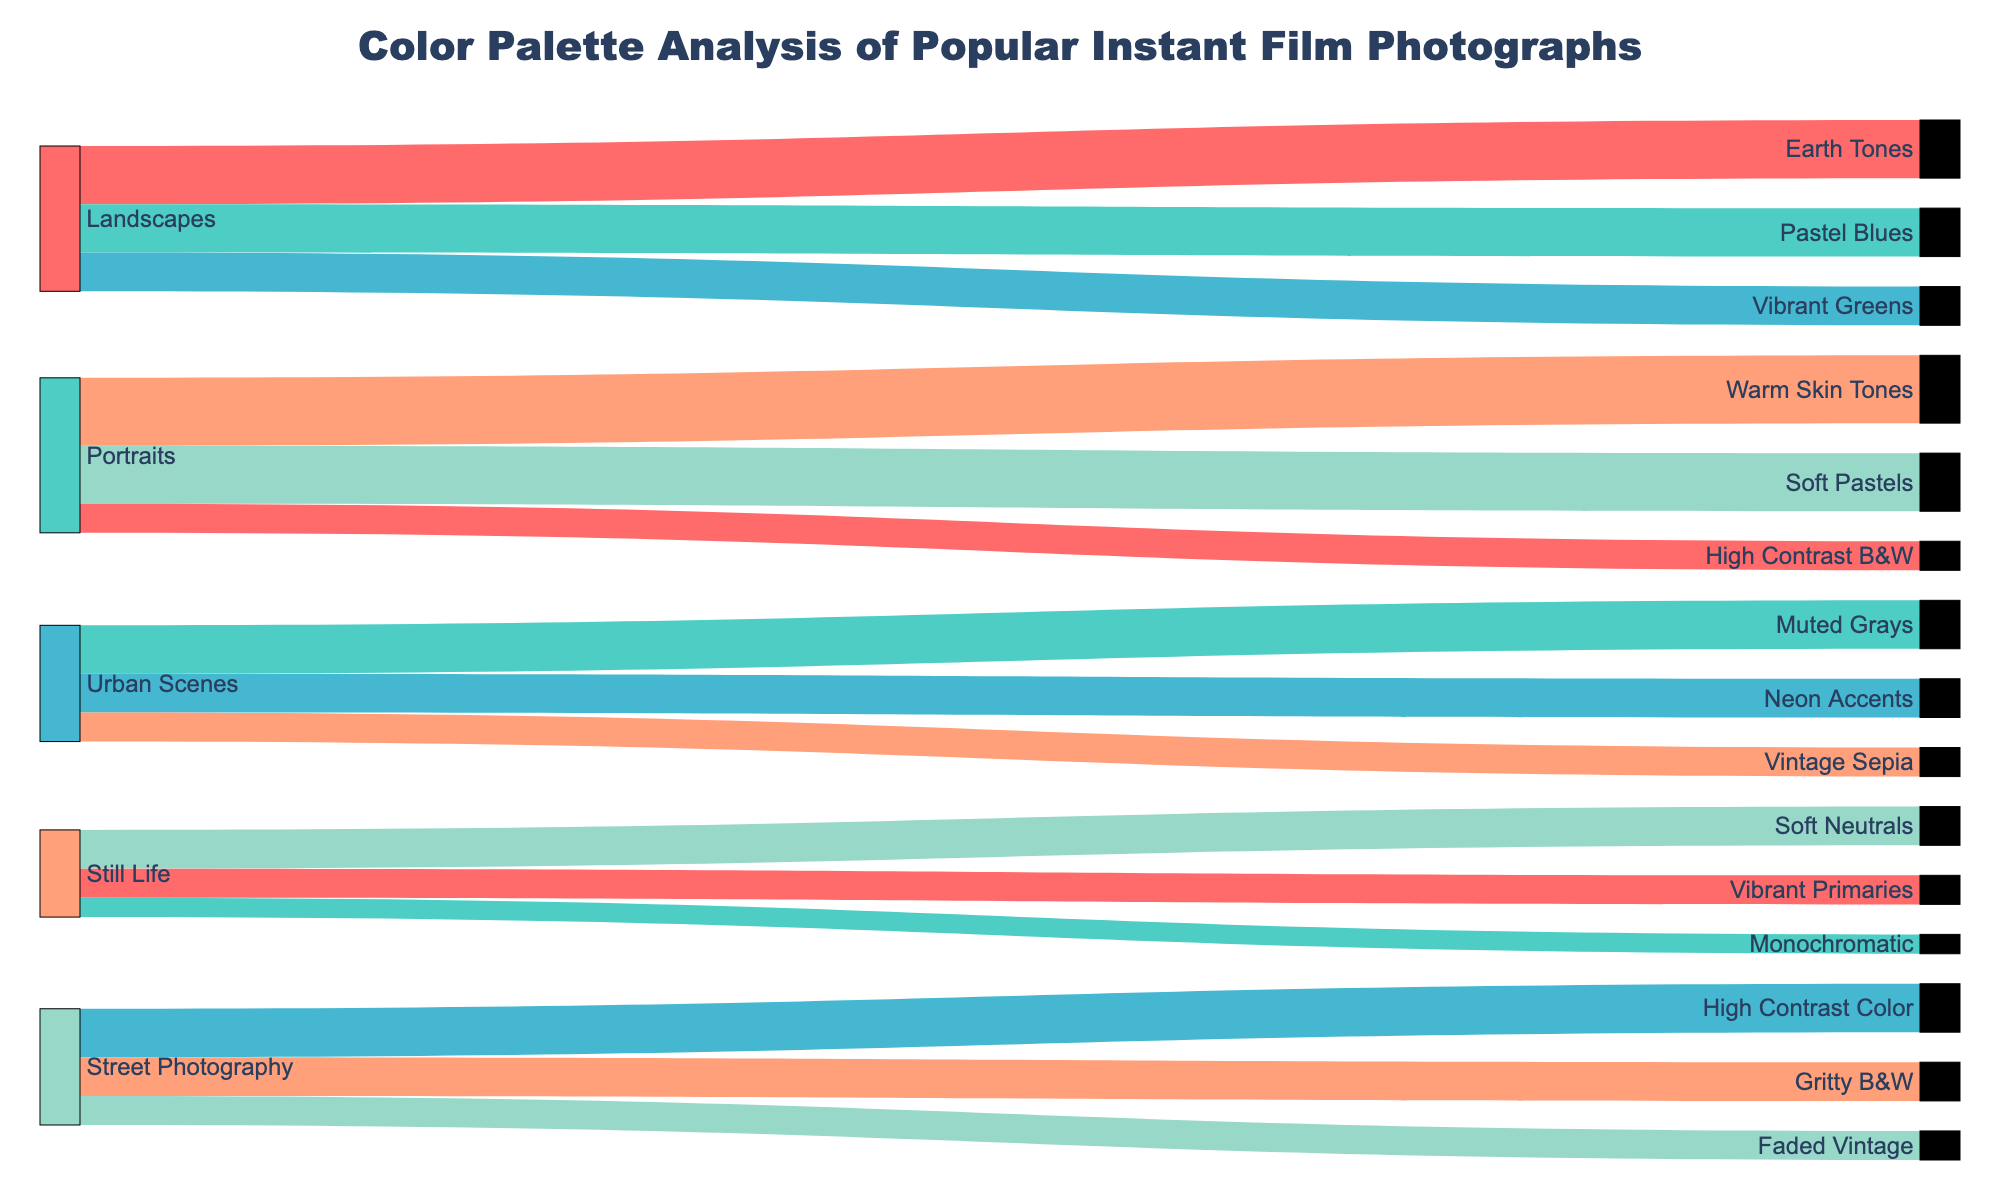What is the title of the figure? The title is usually located at the top of the figure. In this case, it is stated directly in the plot definition section.
Answer: Color Palette Analysis of Popular Instant Film Photographs How many subjects are analyzed in the chart? Count the unique values in the "Subject" column. Here, they are Landscapes, Portraits, Urban Scenes, Still Life, and Street Photography.
Answer: 5 Which color palette has the highest frequency for Portraits? Check the connections starting from Portraits and compare their frequencies: Warm Skin Tones (35), Soft Pastels (30), and High Contrast B&W (15). The highest is Warm Skin Tones.
Answer: Warm Skin Tones Which subject makes the most use of different color palettes? Compare the number of unique color palettes connected to each subject. Landscapes and Portraits each have 3, Urban Scenes, Still Life, and Street Photography each have 3 as well.
Answer: Tied among all subjects How does the usage of Earth Tones in Landscapes compare to Pastel Blues? Check the connections from Landscapes: Earth Tones has a frequency of 30, and Pastel Blues has a frequency of 25. 30 is greater than 25.
Answer: Earth Tones > Pastel Blues What's the total frequency for all Urban Scenes color palettes combined? Sum the frequencies from Urban Scenes: Muted Grays (25) + Neon Accents (20) + Vintage Sepia (15). Total is 25 + 20 + 15 = 60.
Answer: 60 What percentage of Street Photography uses Gritty B&W? First, sum the frequencies for all Street Photography color palettes: High Contrast Color (25) + Gritty B&W (20) + Faded Vintage (15) = 60. Then calculate (20/60)*100 = 33.33%.
Answer: 33.33% Which subject uses Faded Vintage as a color palette, and what is its frequency? Trace the link to Faded Vintage, which connects to Street Photography with a frequency of 15.
Answer: Street Photography, 15 Does any subject share a color palette with both Landscapes and Urban Scenes? If so, which palette? Look for shared links between Landscapes and Urban Scenes: None of the color palettes overlap; they are unique to their subjects.
Answer: No What's the difference in frequency between Muted Grays and Neon Accents in Urban Scenes? Subtract the frequency of Neon Accents (20) from the frequency of Muted Grays (25): 25 - 20 = 5.
Answer: 5 